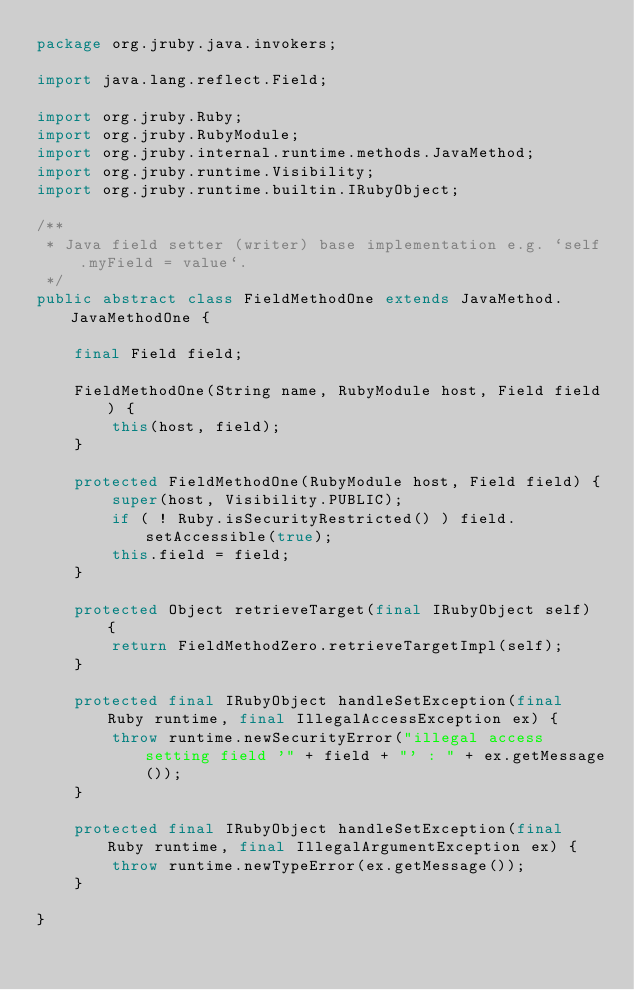Convert code to text. <code><loc_0><loc_0><loc_500><loc_500><_Java_>package org.jruby.java.invokers;

import java.lang.reflect.Field;

import org.jruby.Ruby;
import org.jruby.RubyModule;
import org.jruby.internal.runtime.methods.JavaMethod;
import org.jruby.runtime.Visibility;
import org.jruby.runtime.builtin.IRubyObject;

/**
 * Java field setter (writer) base implementation e.g. `self.myField = value`.
 */
public abstract class FieldMethodOne extends JavaMethod.JavaMethodOne {

    final Field field;

    FieldMethodOne(String name, RubyModule host, Field field) {
        this(host, field);
    }

    protected FieldMethodOne(RubyModule host, Field field) {
        super(host, Visibility.PUBLIC);
        if ( ! Ruby.isSecurityRestricted() ) field.setAccessible(true);
        this.field = field;
    }

    protected Object retrieveTarget(final IRubyObject self) {
        return FieldMethodZero.retrieveTargetImpl(self);
    }

    protected final IRubyObject handleSetException(final Ruby runtime, final IllegalAccessException ex) {
        throw runtime.newSecurityError("illegal access setting field '" + field + "' : " + ex.getMessage());
    }

    protected final IRubyObject handleSetException(final Ruby runtime, final IllegalArgumentException ex) {
        throw runtime.newTypeError(ex.getMessage());
    }

}
</code> 